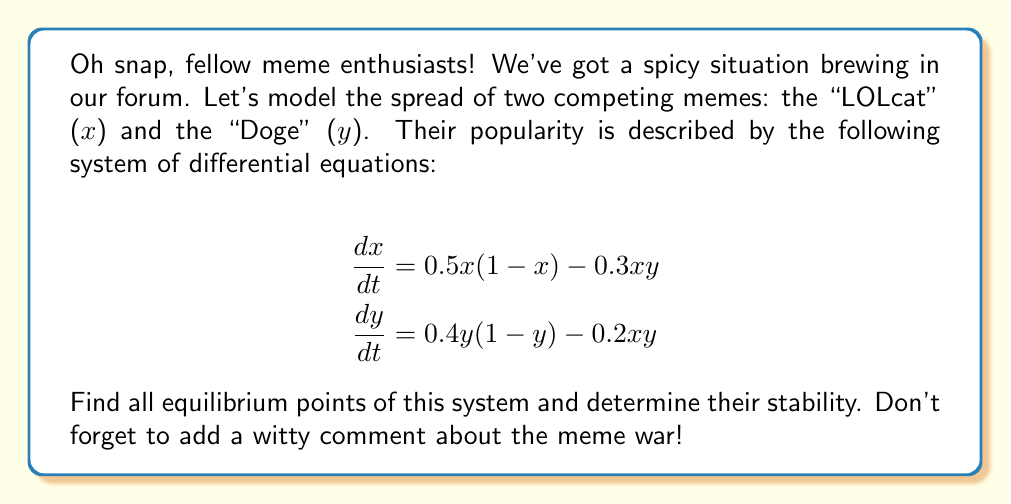Could you help me with this problem? Alright, let's dive into this meme-tastic problem with some math wizardry!

Step 1: Find the equilibrium points
To find the equilibrium points, we set both equations equal to zero:

$$\begin{align}
0.5x(1-x) - 0.3xy &= 0 \\
0.4y(1-y) - 0.2xy &= 0
\end{align}$$

Step 2: Solve for trivial equilibrium points
Clearly, $(0,0)$ is an equilibrium point. Also, $(1,0)$ and $(0,1)$ satisfy the equations.

Step 3: Solve for non-trivial equilibrium point
Factor out $x$ and $y$ from each equation:

$$\begin{align}
x(0.5 - 0.5x - 0.3y) &= 0 \\
y(0.4 - 0.4y - 0.2x) &= 0
\end{align}$$

For non-zero $x$ and $y$, we can set the terms in parentheses to zero and solve:

$$\begin{align}
0.5 - 0.5x - 0.3y &= 0 \\
0.4 - 0.4y - 0.2x &= 0
\end{align}$$

Solving this system (you can use substitution or elimination), we get:
$x = \frac{5}{8}$ and $y = \frac{1}{2}$

Step 4: Determine stability
To determine stability, we need to calculate the Jacobian matrix and evaluate it at each equilibrium point:

$$J = \begin{bmatrix}
0.5 - x - 0.3y & -0.3x \\
-0.2y & 0.4 - 0.8y - 0.2x
\end{bmatrix}$$

For $(0,0)$:
$$J_{(0,0)} = \begin{bmatrix}
0.5 & 0 \\
0 & 0.4
\end{bmatrix}$$
Both eigenvalues are positive, so this is an unstable node.

For $(1,0)$:
$$J_{(1,0)} = \begin{bmatrix}
-0.5 & -0.3 \\
0 & 0.2
\end{bmatrix}$$
One positive and one negative eigenvalue, so this is a saddle point.

For $(0,1)$:
$$J_{(0,1)} = \begin{bmatrix}
0.2 & 0 \\
-0.2 & -0.4
\end{bmatrix}$$
One positive and one negative eigenvalue, so this is also a saddle point.

For $(\frac{5}{8}, \frac{1}{2})$:
$$J_{(\frac{5}{8}, \frac{1}{2})} = \begin{bmatrix}
-0.0625 & -0.1875 \\
-0.1 & -0.125
\end{bmatrix}$$
Both eigenvalues have negative real parts, so this is a stable node.

Step 5: Add a witty comment
Looks like the LOLcats and Doges are destined for peaceful coexistence. No need to call the meme police!
Answer: Equilibrium points: $(0,0)$ (unstable node), $(1,0)$ (saddle), $(0,1)$ (saddle), $(\frac{5}{8}, \frac{1}{2})$ (stable node). 